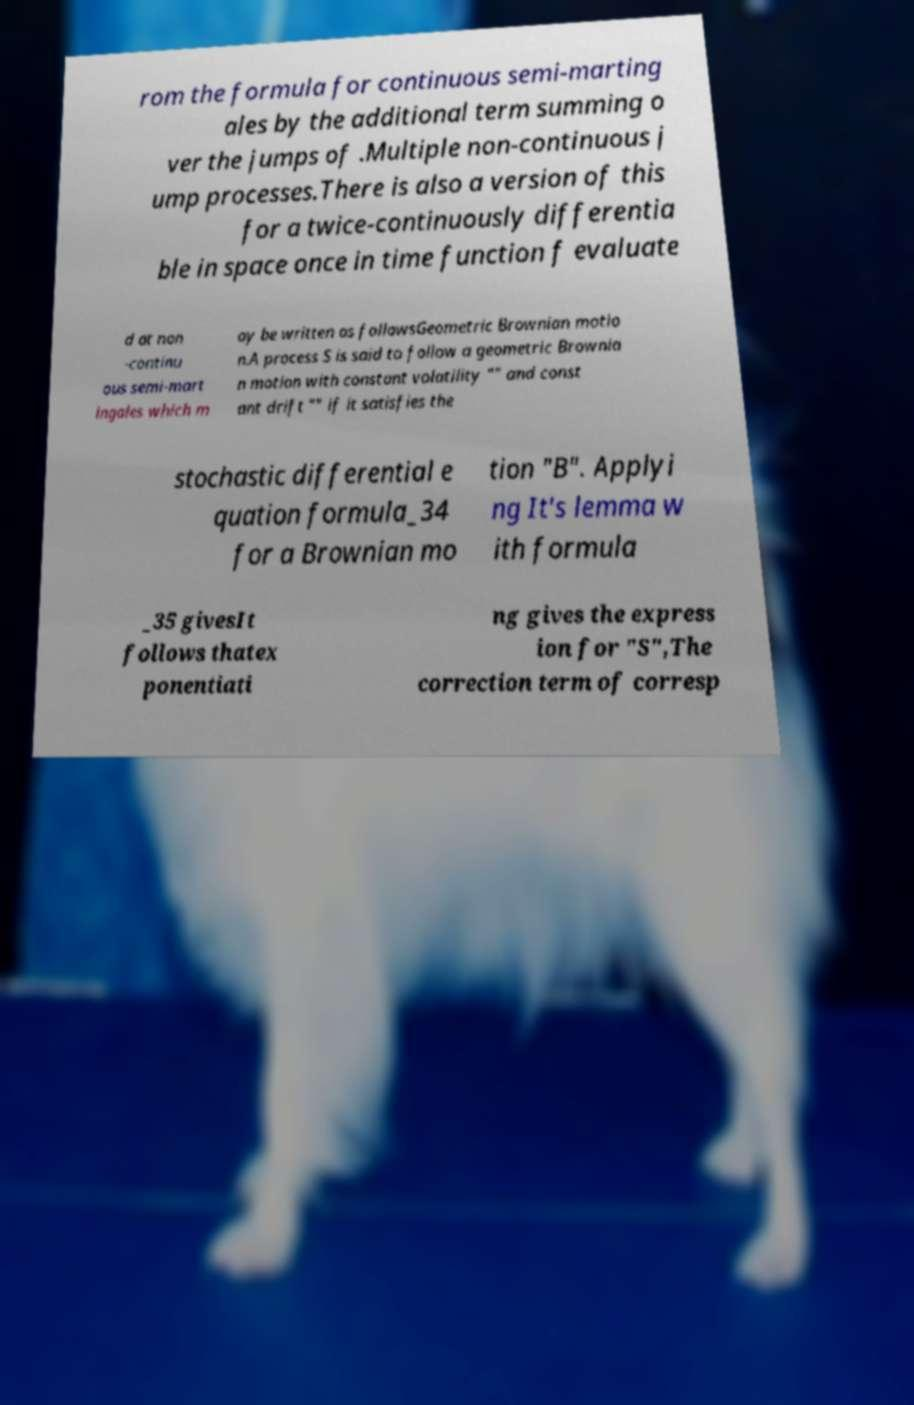For documentation purposes, I need the text within this image transcribed. Could you provide that? rom the formula for continuous semi-marting ales by the additional term summing o ver the jumps of .Multiple non-continuous j ump processes.There is also a version of this for a twice-continuously differentia ble in space once in time function f evaluate d at non -continu ous semi-mart ingales which m ay be written as followsGeometric Brownian motio n.A process S is said to follow a geometric Brownia n motion with constant volatility "" and const ant drift "" if it satisfies the stochastic differential e quation formula_34 for a Brownian mo tion "B". Applyi ng It's lemma w ith formula _35 givesIt follows thatex ponentiati ng gives the express ion for "S",The correction term of corresp 